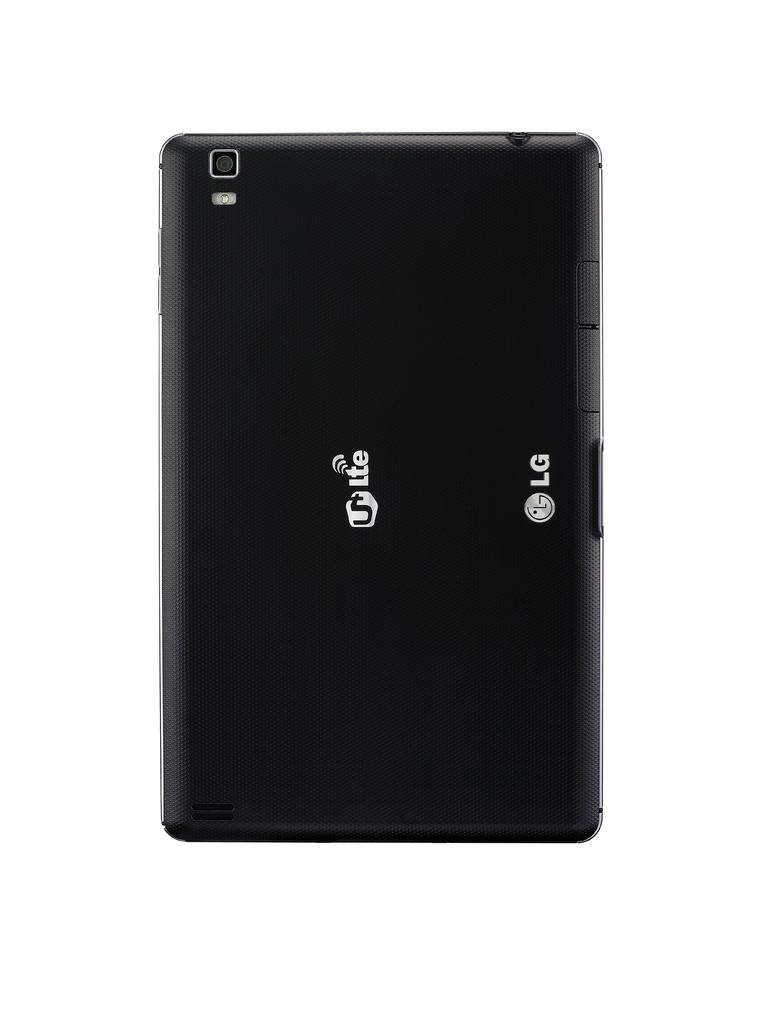Does this support lte?
Ensure brevity in your answer.  Yes. 